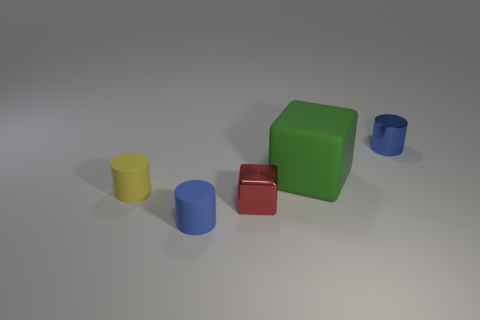Can you tell me about the lighting in the scene? Certainly, the scene is softly lit from above, casting gentle shadows beneath the shapes. The lighting helps to enhance the three-dimensional quality of the objects and gives the image a calm, almost studio-like atmosphere. 